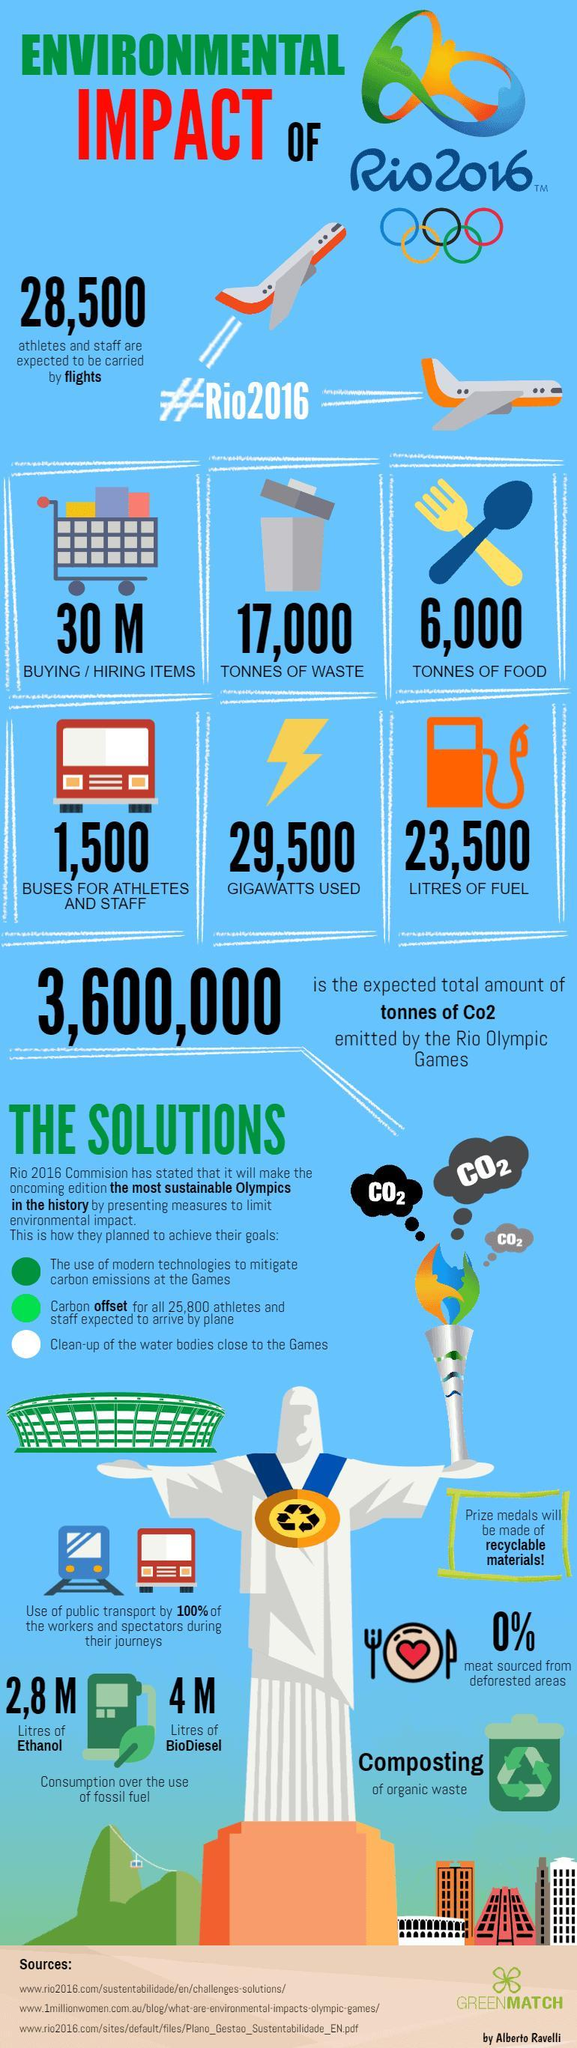What was the amount of waste generated during Olympics 2016 in tons, 17,000, 6,000,or 29,500?
Answer the question with a short phrase. 17,000 